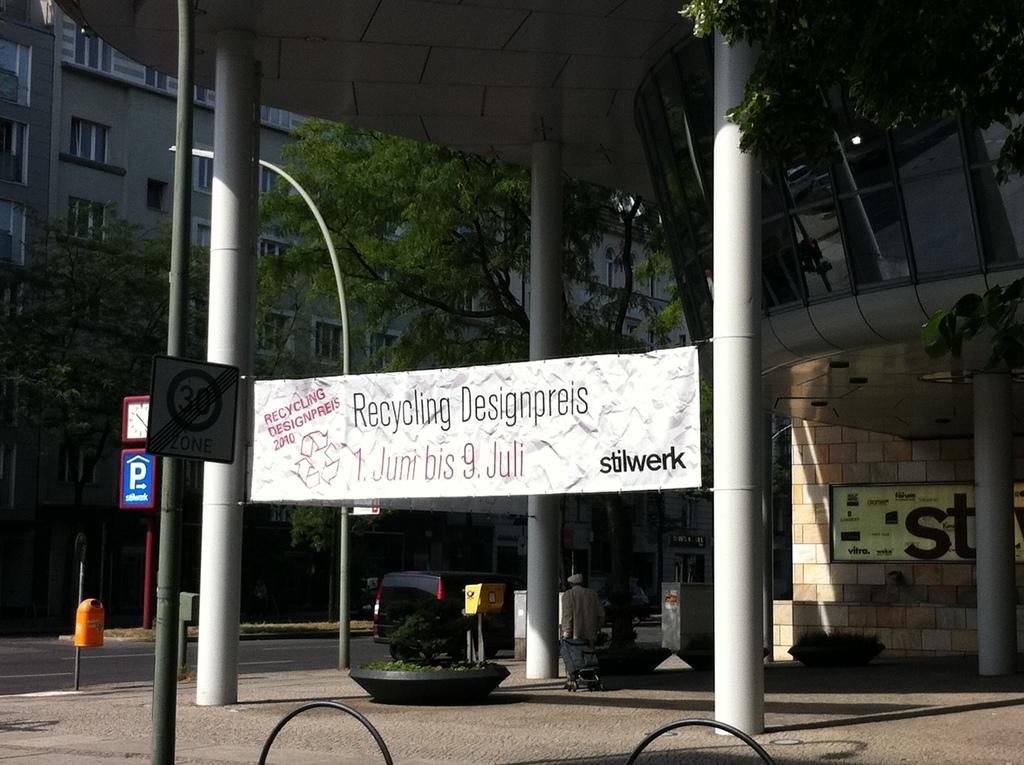What is hanging in the image? There is a banner in the image. What can be seen on the banner? The banner has something written on it. How is the banner secured in the image? The banner is tightened to a pole on either side. What can be seen in the distance in the image? There are buildings and trees in the background of the image. What type of grain is being advertised on the cake in the image? There is no cake or grain present in the image; it features a banner with something written on it. 